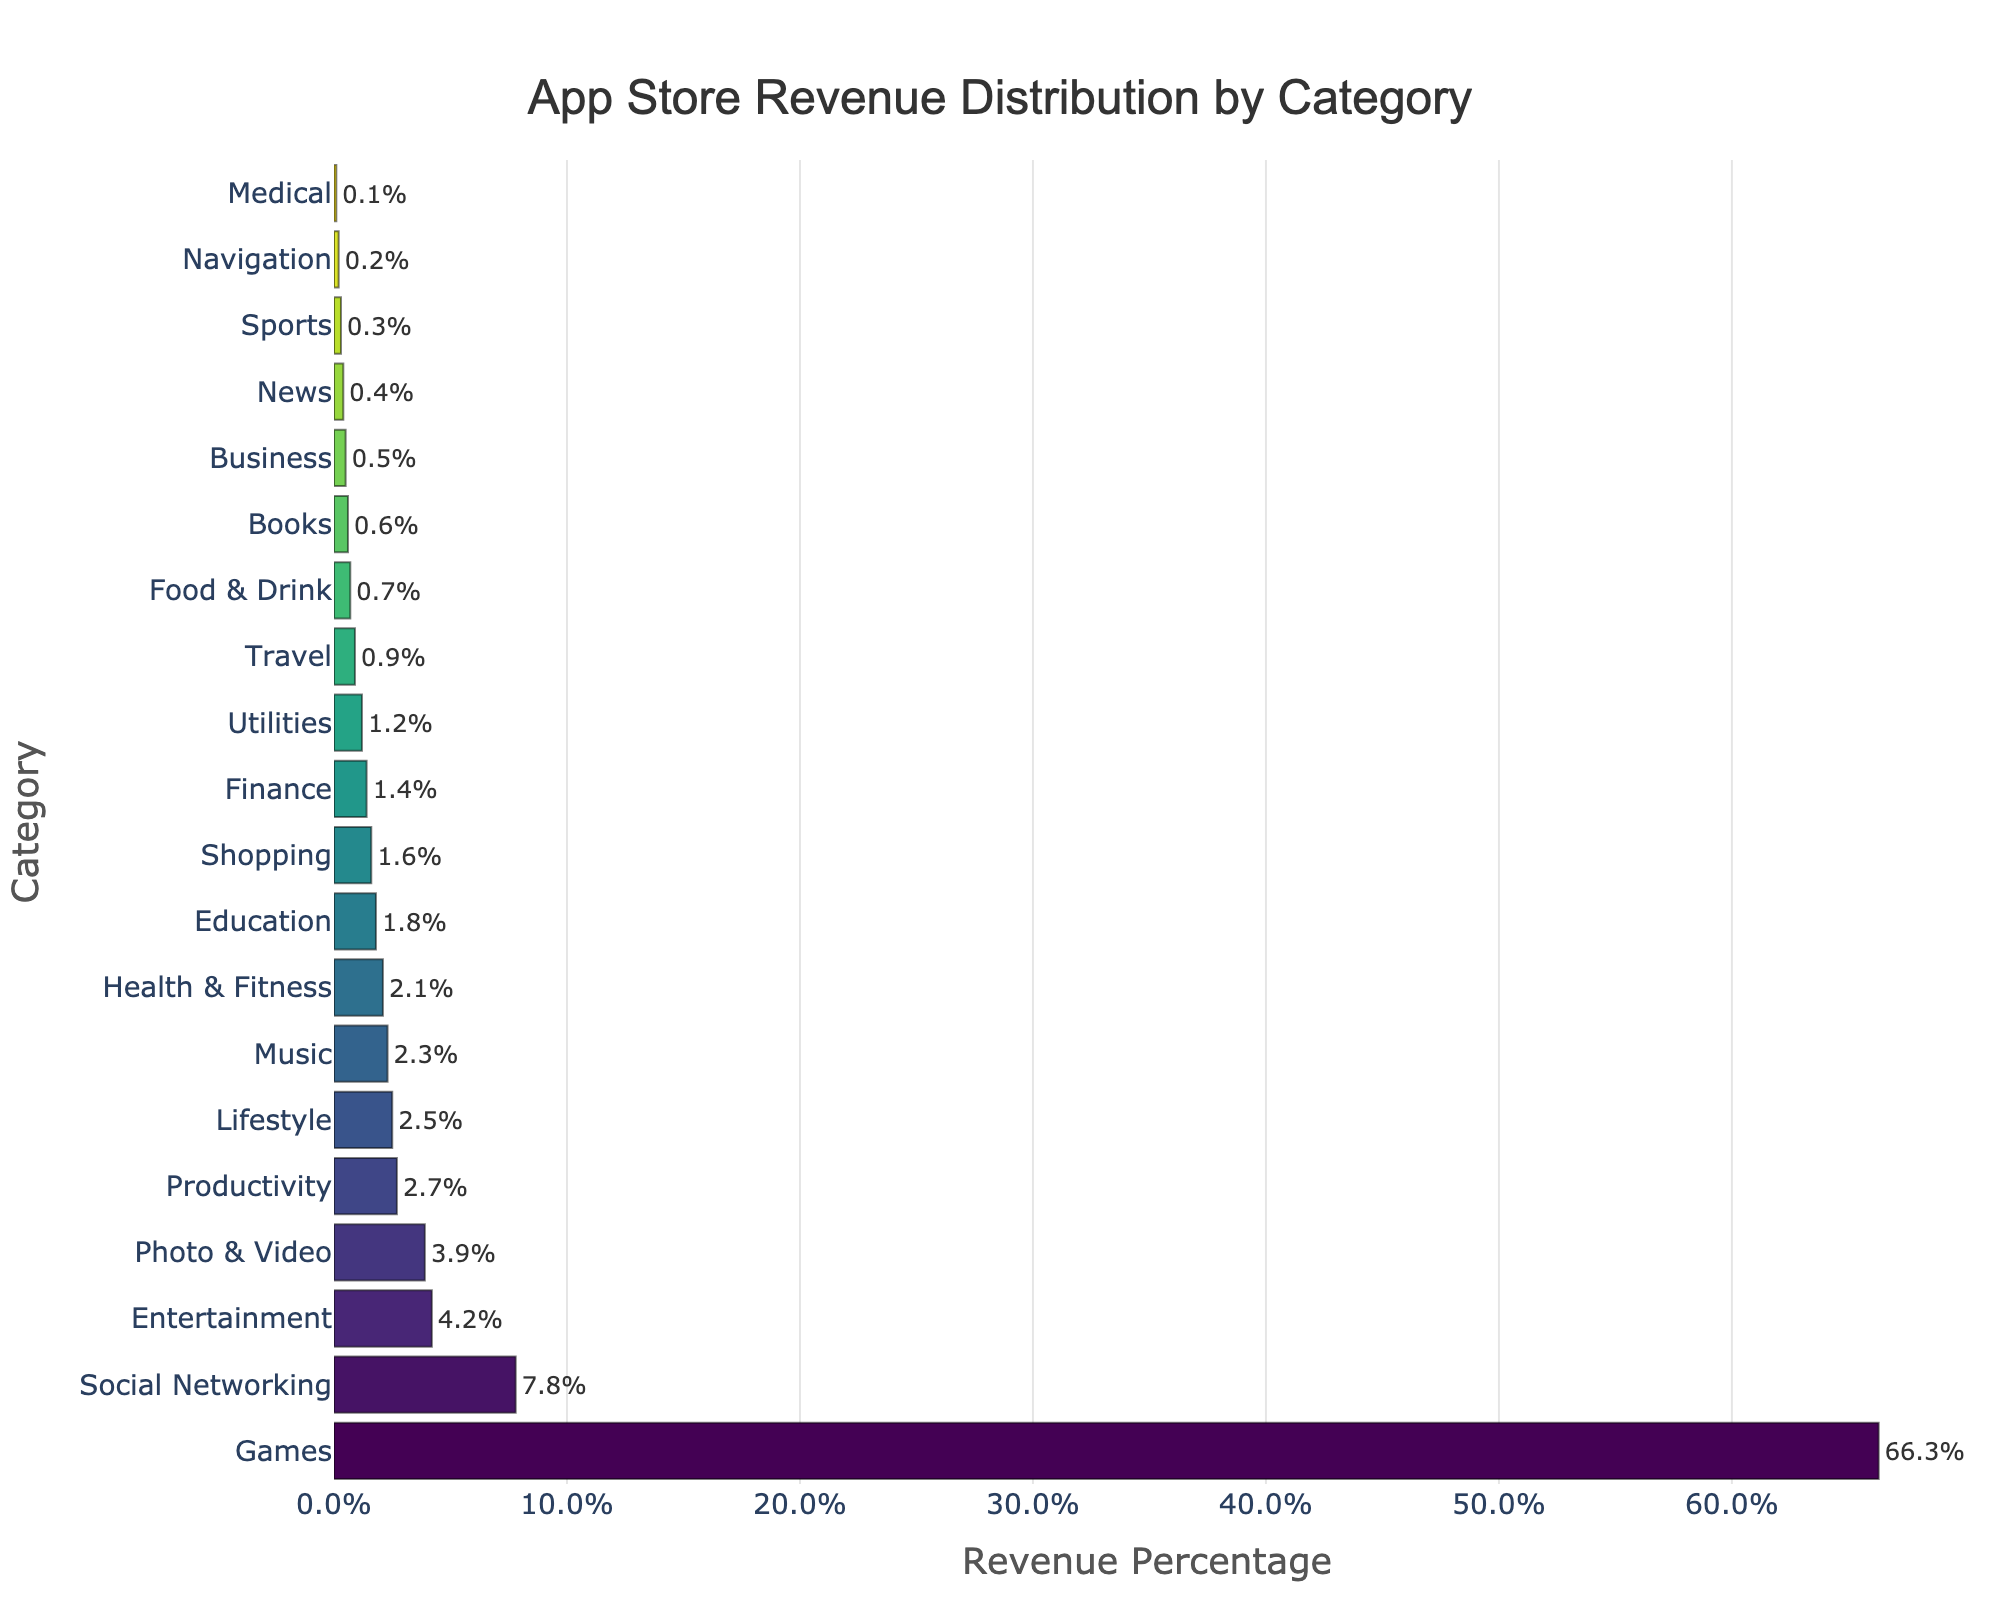What's the category with the highest revenue percentage? By examining the height of the bars, the 'Games' category has the tallest bar, indicating that it has the highest revenue percentage.
Answer: Games What is the combined revenue percentage of the top three categories? The top three categories are 'Games', 'Social Networking', and 'Entertainment'. Adding their values: 66.3% + 7.8% + 4.2% = 78.3%.
Answer: 78.3% Which category has a higher revenue percentage, 'Music' or 'Productivity'? Comparing the bars for the 'Music' and 'Productivity' categories visually, the 'Productivity' category has a slightly taller bar with 2.7% compared to 'Music' at 2.3%.
Answer: Productivity How many categories have a revenue percentage of 2% or higher? Visually counting all categories with bars reaching 2% or higher, we find 'Games', 'Social Networking', 'Entertainment', 'Photo & Video', 'Productivity', 'Lifestyle', 'Music', and 'Health & Fitness', totaling 8 categories.
Answer: 8 What is the smallest revenue percentage shown in the chart? By examining the bars, the 'Medical' category has the smallest bar, indicating a revenue percentage of 0.1%.
Answer: 0.1% What is the difference in revenue percentage between 'Health & Fitness' and 'Education' categories? The 'Health & Fitness' category has a revenue percentage of 2.1% and the 'Education' category has 1.8%, so the difference is 2.1% - 1.8% = 0.3%.
Answer: 0.3% Which categories have revenue percentages below 1%? The categories with the smallest bars below 1% include 'Travel', 'Food & Drink', 'Books', 'Business', 'News', 'Sports', 'Navigation', and 'Medical'.
Answer: 8 Is the revenue percentage of 'Shopping' higher than 'Finance'? Comparing the bars for 'Shopping' and 'Finance', 'Shopping' has a bar with 1.6%, while 'Finance' has a bar with 1.4%. Thus, 'Shopping' is higher.
Answer: Yes What's the average revenue percentage for 'Food & Drink', 'Books', and 'Business'? Adding the percentages and dividing by 3: (0.7% + 0.6% + 0.5%) / 3 = 0.6%.
Answer: 0.6% 